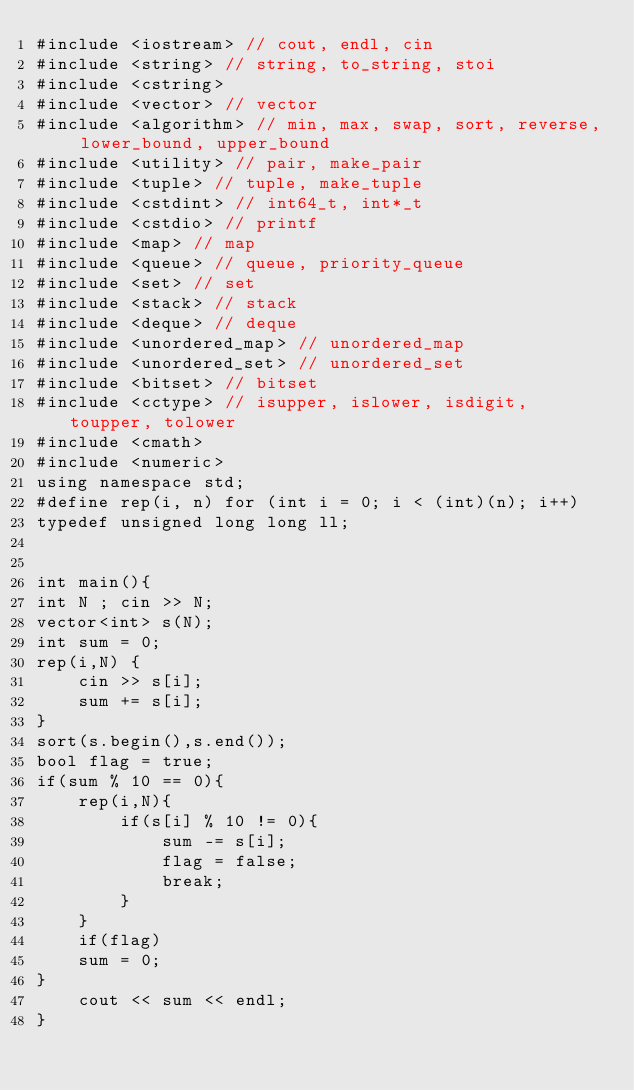Convert code to text. <code><loc_0><loc_0><loc_500><loc_500><_C++_>#include <iostream> // cout, endl, cin
#include <string> // string, to_string, stoi
#include <cstring>
#include <vector> // vector
#include <algorithm> // min, max, swap, sort, reverse, lower_bound, upper_bound
#include <utility> // pair, make_pair
#include <tuple> // tuple, make_tuple
#include <cstdint> // int64_t, int*_t
#include <cstdio> // printf
#include <map> // map
#include <queue> // queue, priority_queue
#include <set> // set
#include <stack> // stack
#include <deque> // deque
#include <unordered_map> // unordered_map
#include <unordered_set> // unordered_set
#include <bitset> // bitset
#include <cctype> // isupper, islower, isdigit, toupper, tolower
#include <cmath>
#include <numeric>
using namespace std;
#define rep(i, n) for (int i = 0; i < (int)(n); i++)
typedef unsigned long long ll;


int main(){
int N ; cin >> N;
vector<int> s(N);
int sum = 0;
rep(i,N) {
	cin >> s[i];
	sum += s[i];
}
sort(s.begin(),s.end());
bool flag = true;
if(sum % 10 == 0){
	rep(i,N){
		if(s[i] % 10 != 0){
			sum -= s[i];
			flag = false;
			break;
		}
	}
	if(flag)
	sum = 0;
}
	cout << sum << endl;
}</code> 